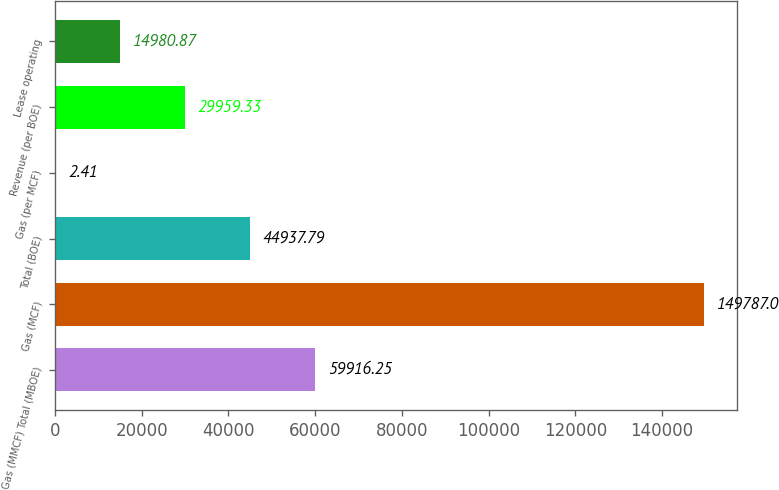Convert chart. <chart><loc_0><loc_0><loc_500><loc_500><bar_chart><fcel>Gas (MMCF) Total (MBOE)<fcel>Gas (MCF)<fcel>Total (BOE)<fcel>Gas (per MCF)<fcel>Revenue (per BOE)<fcel>Lease operating<nl><fcel>59916.2<fcel>149787<fcel>44937.8<fcel>2.41<fcel>29959.3<fcel>14980.9<nl></chart> 